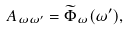<formula> <loc_0><loc_0><loc_500><loc_500>A _ { \omega \omega ^ { \prime } } = { \widetilde { \Phi } } _ { \omega } ( \omega ^ { \prime } ) ,</formula> 